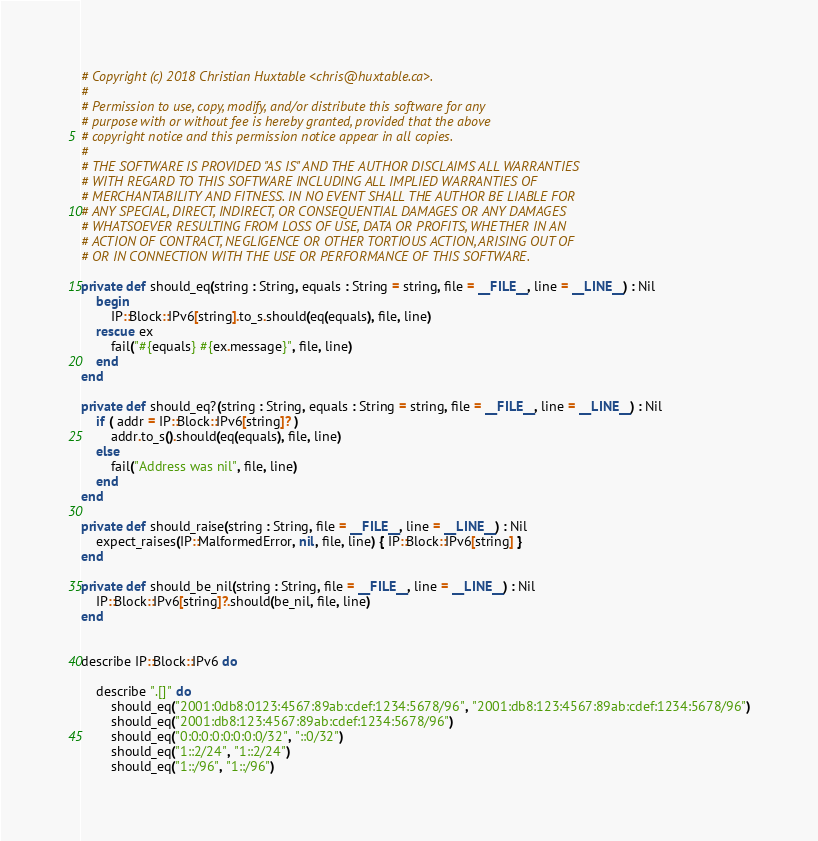Convert code to text. <code><loc_0><loc_0><loc_500><loc_500><_Crystal_># Copyright (c) 2018 Christian Huxtable <chris@huxtable.ca>.
#
# Permission to use, copy, modify, and/or distribute this software for any
# purpose with or without fee is hereby granted, provided that the above
# copyright notice and this permission notice appear in all copies.
#
# THE SOFTWARE IS PROVIDED "AS IS" AND THE AUTHOR DISCLAIMS ALL WARRANTIES
# WITH REGARD TO THIS SOFTWARE INCLUDING ALL IMPLIED WARRANTIES OF
# MERCHANTABILITY AND FITNESS. IN NO EVENT SHALL THE AUTHOR BE LIABLE FOR
# ANY SPECIAL, DIRECT, INDIRECT, OR CONSEQUENTIAL DAMAGES OR ANY DAMAGES
# WHATSOEVER RESULTING FROM LOSS OF USE, DATA OR PROFITS, WHETHER IN AN
# ACTION OF CONTRACT, NEGLIGENCE OR OTHER TORTIOUS ACTION, ARISING OUT OF
# OR IN CONNECTION WITH THE USE OR PERFORMANCE OF THIS SOFTWARE.

private def should_eq(string : String, equals : String = string, file = __FILE__, line = __LINE__) : Nil
	begin
		IP::Block::IPv6[string].to_s.should(eq(equals), file, line)
	rescue ex
		fail("#{equals} #{ex.message}", file, line)
	end
end

private def should_eq?(string : String, equals : String = string, file = __FILE__, line = __LINE__) : Nil
	if ( addr = IP::Block::IPv6[string]? )
		addr.to_s().should(eq(equals), file, line)
	else
		fail("Address was nil", file, line)
	end
end

private def should_raise(string : String, file = __FILE__, line = __LINE__) : Nil
	expect_raises(IP::MalformedError, nil, file, line) { IP::Block::IPv6[string] }
end

private def should_be_nil(string : String, file = __FILE__, line = __LINE__) : Nil
	IP::Block::IPv6[string]?.should(be_nil, file, line)
end


describe IP::Block::IPv6 do

	describe ".[]" do
		should_eq("2001:0db8:0123:4567:89ab:cdef:1234:5678/96", "2001:db8:123:4567:89ab:cdef:1234:5678/96")
		should_eq("2001:db8:123:4567:89ab:cdef:1234:5678/96")
		should_eq("0:0:0:0:0:0:0:0/32", "::0/32")
		should_eq("1::2/24", "1::2/24")
		should_eq("1::/96", "1::/96")</code> 